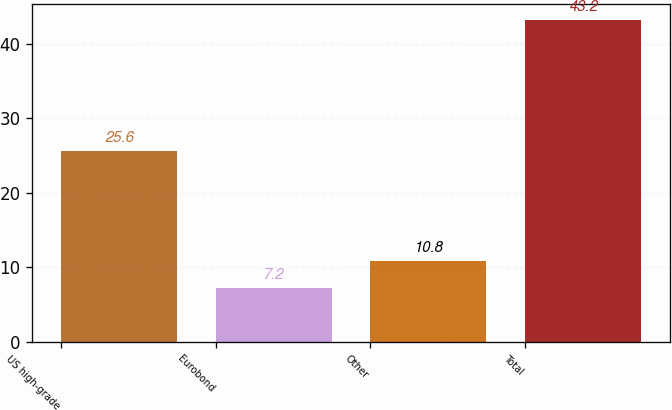Convert chart to OTSL. <chart><loc_0><loc_0><loc_500><loc_500><bar_chart><fcel>US high-grade<fcel>Eurobond<fcel>Other<fcel>Total<nl><fcel>25.6<fcel>7.2<fcel>10.8<fcel>43.2<nl></chart> 